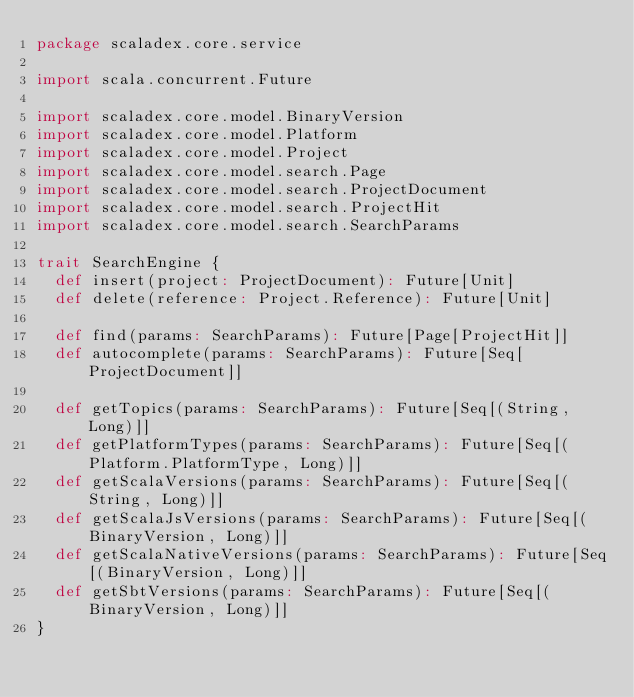Convert code to text. <code><loc_0><loc_0><loc_500><loc_500><_Scala_>package scaladex.core.service

import scala.concurrent.Future

import scaladex.core.model.BinaryVersion
import scaladex.core.model.Platform
import scaladex.core.model.Project
import scaladex.core.model.search.Page
import scaladex.core.model.search.ProjectDocument
import scaladex.core.model.search.ProjectHit
import scaladex.core.model.search.SearchParams

trait SearchEngine {
  def insert(project: ProjectDocument): Future[Unit]
  def delete(reference: Project.Reference): Future[Unit]

  def find(params: SearchParams): Future[Page[ProjectHit]]
  def autocomplete(params: SearchParams): Future[Seq[ProjectDocument]]

  def getTopics(params: SearchParams): Future[Seq[(String, Long)]]
  def getPlatformTypes(params: SearchParams): Future[Seq[(Platform.PlatformType, Long)]]
  def getScalaVersions(params: SearchParams): Future[Seq[(String, Long)]]
  def getScalaJsVersions(params: SearchParams): Future[Seq[(BinaryVersion, Long)]]
  def getScalaNativeVersions(params: SearchParams): Future[Seq[(BinaryVersion, Long)]]
  def getSbtVersions(params: SearchParams): Future[Seq[(BinaryVersion, Long)]]
}
</code> 